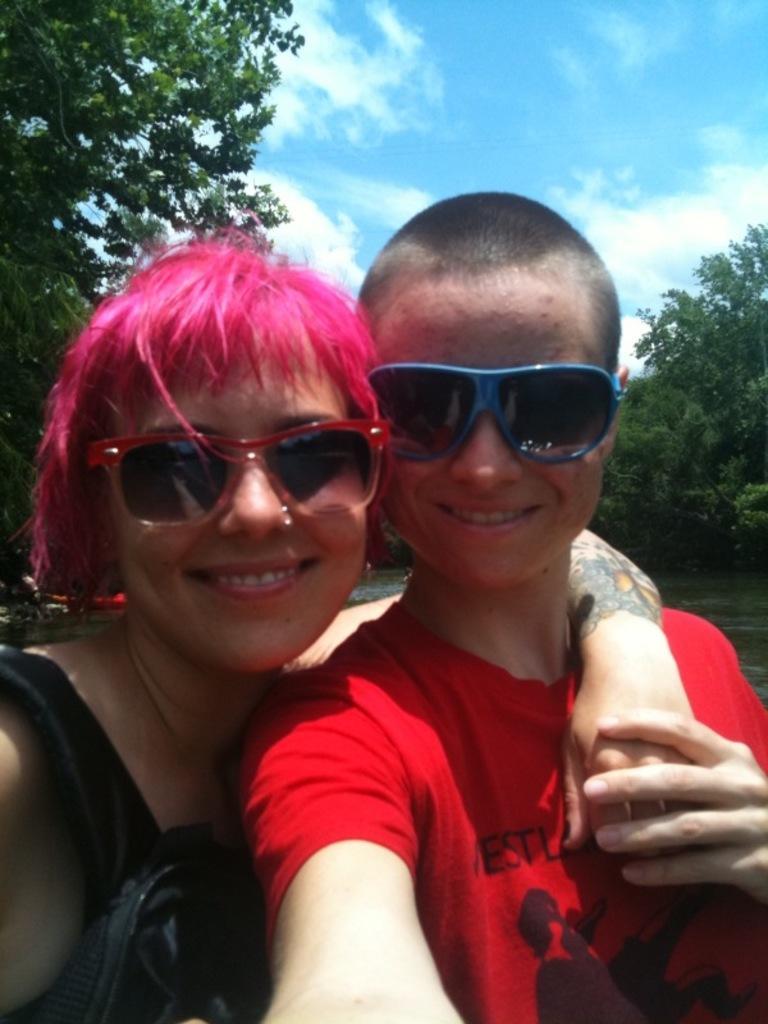Can you describe this image briefly? In this picture I can see there is a woman and a boy, they are wearing goggles and the boy is wearing a red color shirt and in the backdrop I can see there is a lake and trees, the sky is clear. 